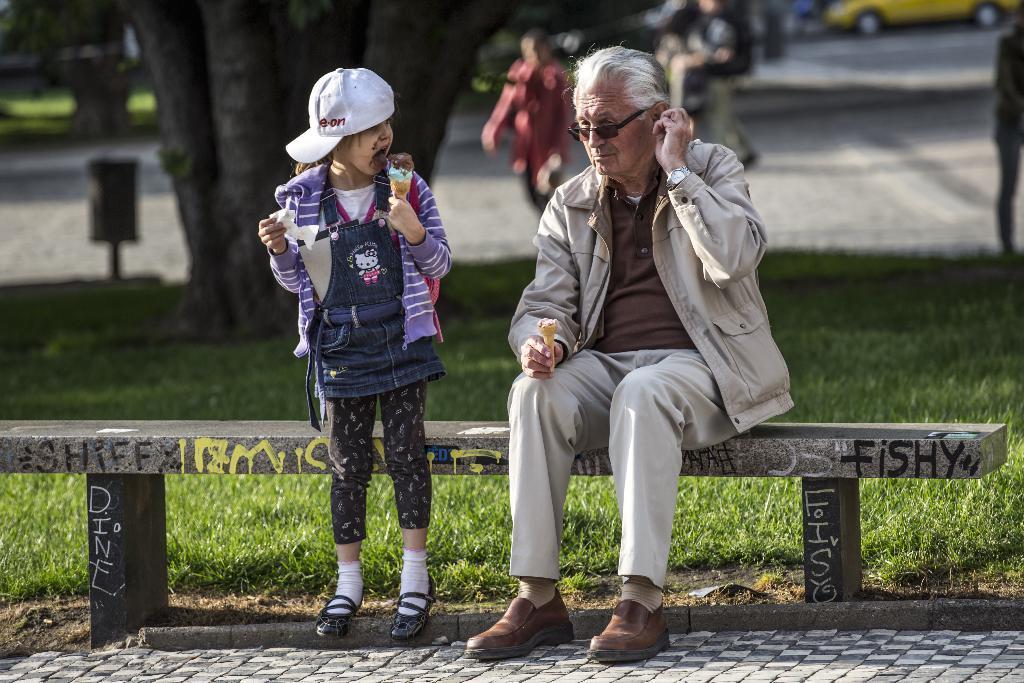How would you summarize this image in a sentence or two? Here we can see a old man sitting on a bench with a ice cream in his hand and beside him there is a child who is eating ice cream which is present in her hand and behind them we can see group of people walking and there is a car at the top right and there are trees 